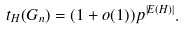<formula> <loc_0><loc_0><loc_500><loc_500>t _ { H } ( G _ { n } ) = ( 1 + o ( 1 ) ) p ^ { | E ( H ) | } .</formula> 